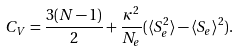Convert formula to latex. <formula><loc_0><loc_0><loc_500><loc_500>C _ { V } = \frac { 3 ( N - 1 ) } { 2 } + \frac { \kappa ^ { 2 } } { N _ { e } } ( \langle S _ { e } ^ { 2 } \rangle - \langle S _ { e } \rangle ^ { 2 } ) .</formula> 